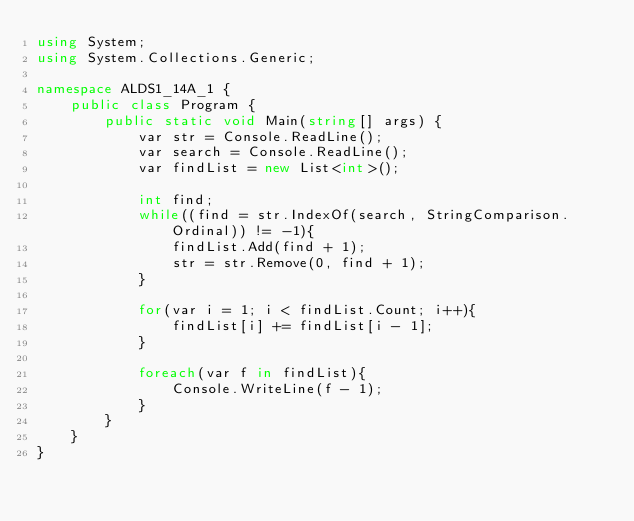<code> <loc_0><loc_0><loc_500><loc_500><_C#_>using System;
using System.Collections.Generic;

namespace ALDS1_14A_1 {
    public class Program {
        public static void Main(string[] args) {
            var str = Console.ReadLine();
            var search = Console.ReadLine();
            var findList = new List<int>();

            int find;
            while((find = str.IndexOf(search, StringComparison.Ordinal)) != -1){
                findList.Add(find + 1);
                str = str.Remove(0, find + 1);
            }

            for(var i = 1; i < findList.Count; i++){
                findList[i] += findList[i - 1];
            }

            foreach(var f in findList){
                Console.WriteLine(f - 1);
            }
        }
    }
}</code> 